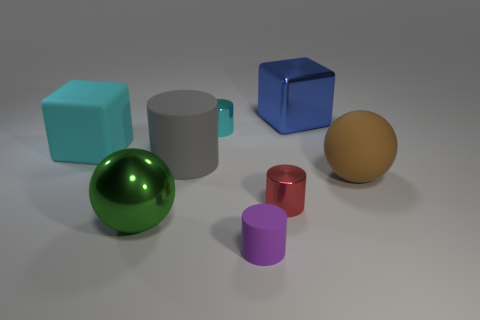Add 2 cyan rubber cubes. How many objects exist? 10 Subtract all small cyan cylinders. How many cylinders are left? 3 Subtract all purple cylinders. How many cylinders are left? 3 Subtract 1 cylinders. How many cylinders are left? 3 Subtract all purple cylinders. Subtract all gray cubes. How many cylinders are left? 3 Subtract 1 red cylinders. How many objects are left? 7 Subtract all cubes. How many objects are left? 6 Subtract all purple objects. Subtract all large rubber blocks. How many objects are left? 6 Add 3 blue metal things. How many blue metal things are left? 4 Add 1 large cyan blocks. How many large cyan blocks exist? 2 